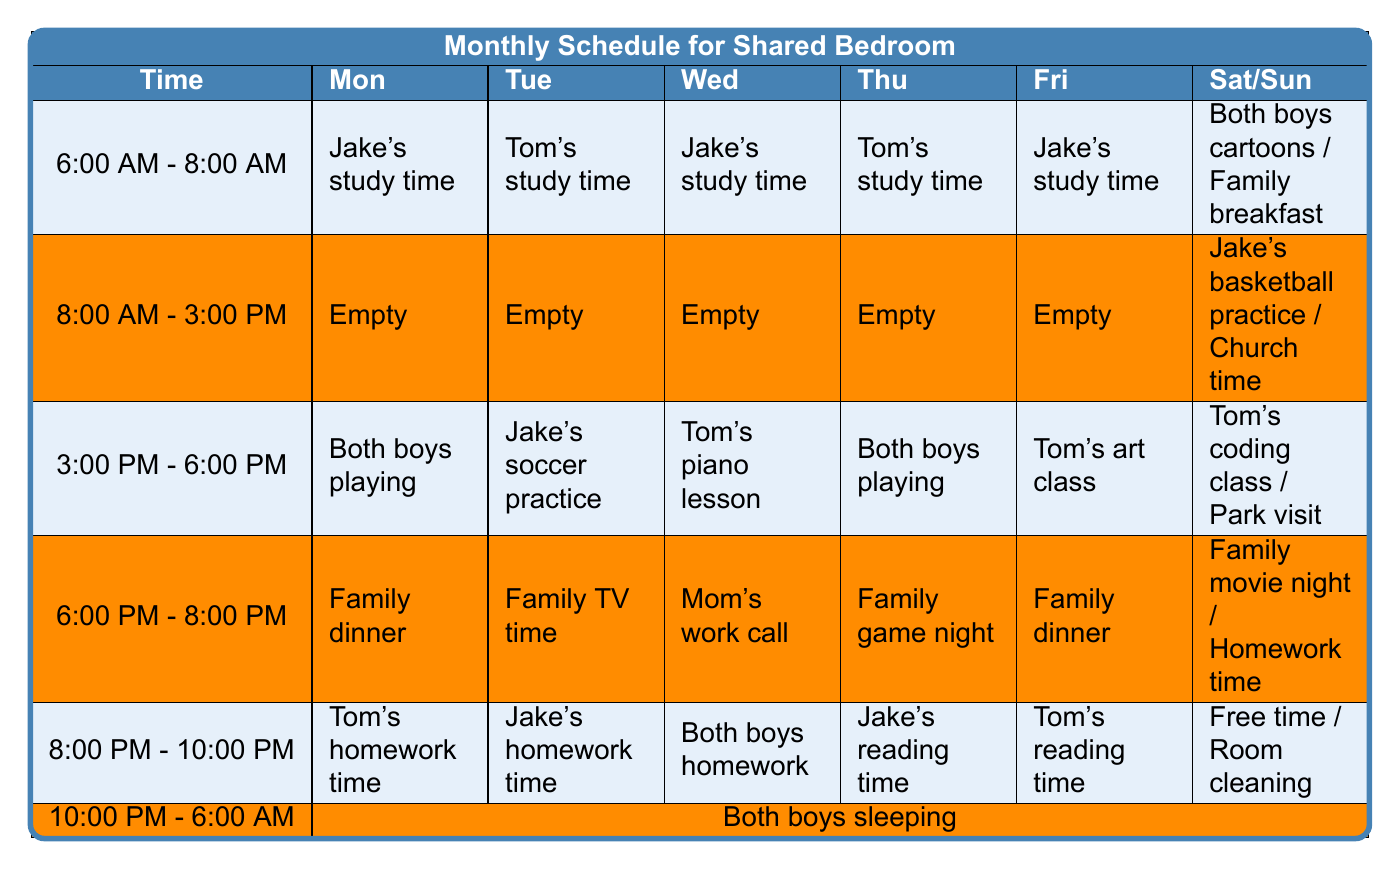What activities are scheduled for the boys during the 6:00 PM - 8:00 PM time slot on Wednesday? According to the table, on Wednesday from 6:00 PM - 8:00 PM, the scheduled activity is "Mom's work call."
Answer: Mom's work call How many slots from 6:00 AM - 8:00 AM are allocated specifically for study time? In the table, there are three time slots (Monday, Tuesday, and Friday) allocated for study time during 6:00 AM - 8:00 AM.
Answer: 3 Is there a time slot where both boys have an activity scheduled together? Yes, during the 3:00 PM - 6:00 PM time slot on Monday and Thursday, both boys are scheduled to play together.
Answer: Yes On which day is "Family dinner" scheduled? "Family dinner" is scheduled on Monday, Friday, and Saturday during the 6:00 PM - 8:00 PM time slot.
Answer: Monday, Friday, Saturday Which time slots are designated for "both boys sleeping"? The time slot for "both boys sleeping" is set for 10:00 PM - 6:00 AM every day of the week.
Answer: 10:00 PM - 6:00 AM How many days include "Tom's study time"? "Tom's study time" appears twice in the table: once on Monday and once on Tuesday.
Answer: 2 What is the total number of distinct activities listed in the entire table? By counting the unique activities mentioned across all days and time slots, there are 11 distinct activities: Jake's study time, Tom's study time, Both boys playing, Family dinner, Tom's homework time, Both boys sleeping, Jake's soccer practice, Family TV time, Tom's piano lesson, and so on. Thus, the total is 11.
Answer: 11 Which day includes "Homework time" and during what slot? "Homework time" is scheduled on Saturday during the 8:00 PM - 10:00 PM time slot.
Answer: Saturday, 8:00 PM - 10:00 PM On which day do both boys start their day together? The boys start their day together on Saturday at 6:00 AM - 8:00 AM with "Both boys cartoons" and "Family breakfast."
Answer: Saturday What is the activity for the 8:00 AM - 3:00 PM slot on Saturday? During the 8:00 AM - 3:00 PM slot on Saturday, the designated activities are "Church time" and "Jake's basketball practice".
Answer: Church time and Jake's basketball practice 